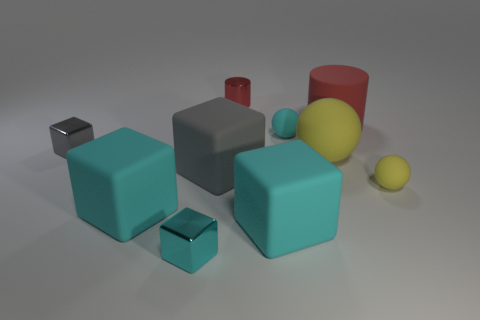Subtract all green balls. How many cyan cubes are left? 3 Subtract all gray blocks. How many blocks are left? 3 Subtract all rubber cubes. How many cubes are left? 2 Subtract all brown blocks. Subtract all gray cylinders. How many blocks are left? 5 Subtract all spheres. How many objects are left? 7 Add 9 red rubber objects. How many red rubber objects are left? 10 Add 9 tiny red cubes. How many tiny red cubes exist? 9 Subtract 0 blue spheres. How many objects are left? 10 Subtract all small red metallic things. Subtract all large yellow things. How many objects are left? 8 